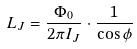Convert formula to latex. <formula><loc_0><loc_0><loc_500><loc_500>L _ { J } = \frac { \Phi _ { 0 } } { 2 \pi I _ { J } } \cdot \frac { 1 } { \cos \phi }</formula> 